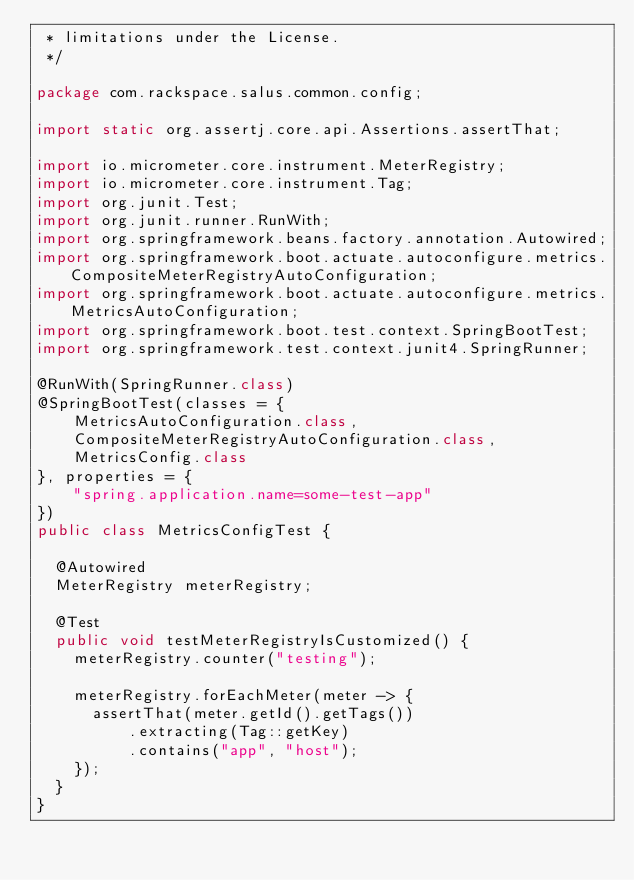Convert code to text. <code><loc_0><loc_0><loc_500><loc_500><_Java_> * limitations under the License.
 */

package com.rackspace.salus.common.config;

import static org.assertj.core.api.Assertions.assertThat;

import io.micrometer.core.instrument.MeterRegistry;
import io.micrometer.core.instrument.Tag;
import org.junit.Test;
import org.junit.runner.RunWith;
import org.springframework.beans.factory.annotation.Autowired;
import org.springframework.boot.actuate.autoconfigure.metrics.CompositeMeterRegistryAutoConfiguration;
import org.springframework.boot.actuate.autoconfigure.metrics.MetricsAutoConfiguration;
import org.springframework.boot.test.context.SpringBootTest;
import org.springframework.test.context.junit4.SpringRunner;

@RunWith(SpringRunner.class)
@SpringBootTest(classes = {
    MetricsAutoConfiguration.class,
    CompositeMeterRegistryAutoConfiguration.class,
    MetricsConfig.class
}, properties = {
    "spring.application.name=some-test-app"
})
public class MetricsConfigTest {

  @Autowired
  MeterRegistry meterRegistry;

  @Test
  public void testMeterRegistryIsCustomized() {
    meterRegistry.counter("testing");

    meterRegistry.forEachMeter(meter -> {
      assertThat(meter.getId().getTags())
          .extracting(Tag::getKey)
          .contains("app", "host");
    });
  }
}</code> 